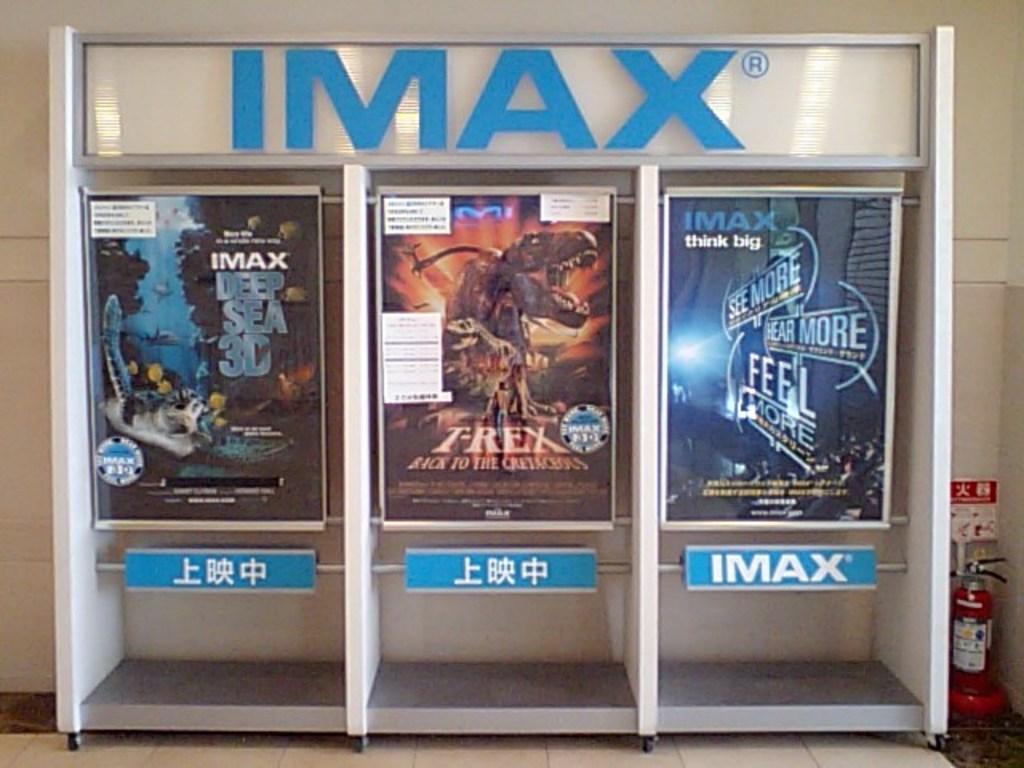What type of movie theater is this?
Give a very brief answer. Imax. What movie is showing?
Offer a terse response. T-rex. 